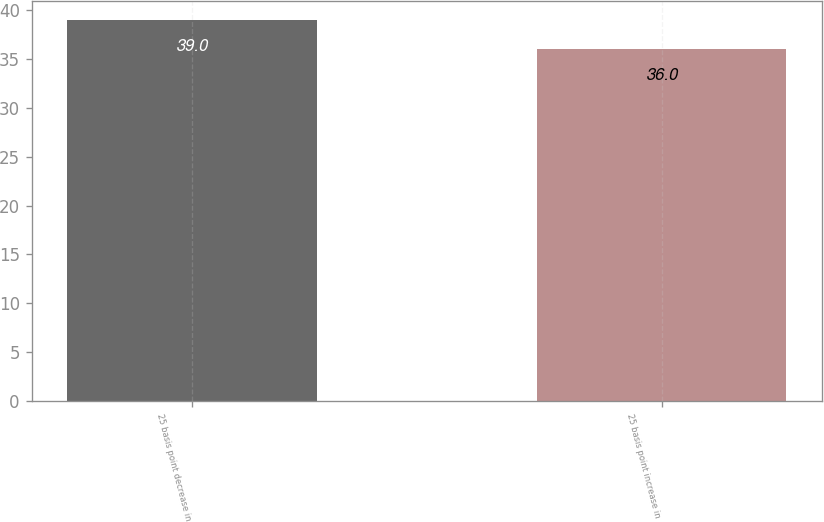Convert chart. <chart><loc_0><loc_0><loc_500><loc_500><bar_chart><fcel>25 basis point decrease in<fcel>25 basis point increase in<nl><fcel>39<fcel>36<nl></chart> 